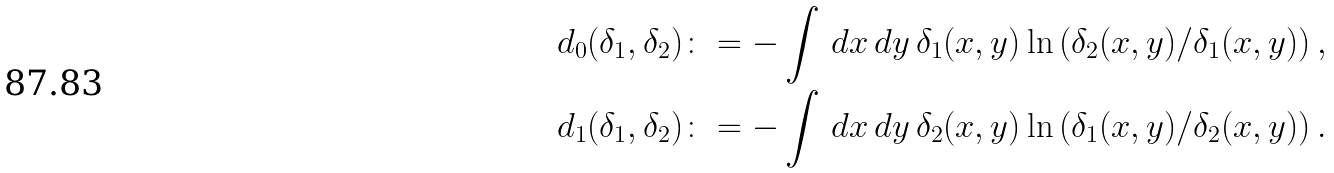<formula> <loc_0><loc_0><loc_500><loc_500>d _ { 0 } ( \delta _ { 1 } , \delta _ { 2 } ) & \colon = - \int \, d x \, d y \, \delta _ { 1 } ( x , y ) \ln \left ( \delta _ { 2 } ( x , y ) / \delta _ { 1 } ( x , y ) \right ) , \\ d _ { 1 } ( \delta _ { 1 } , \delta _ { 2 } ) & \colon = - \int \, d x \, d y \, \delta _ { 2 } ( x , y ) \ln \left ( \delta _ { 1 } ( x , y ) / \delta _ { 2 } ( x , y ) \right ) .</formula> 